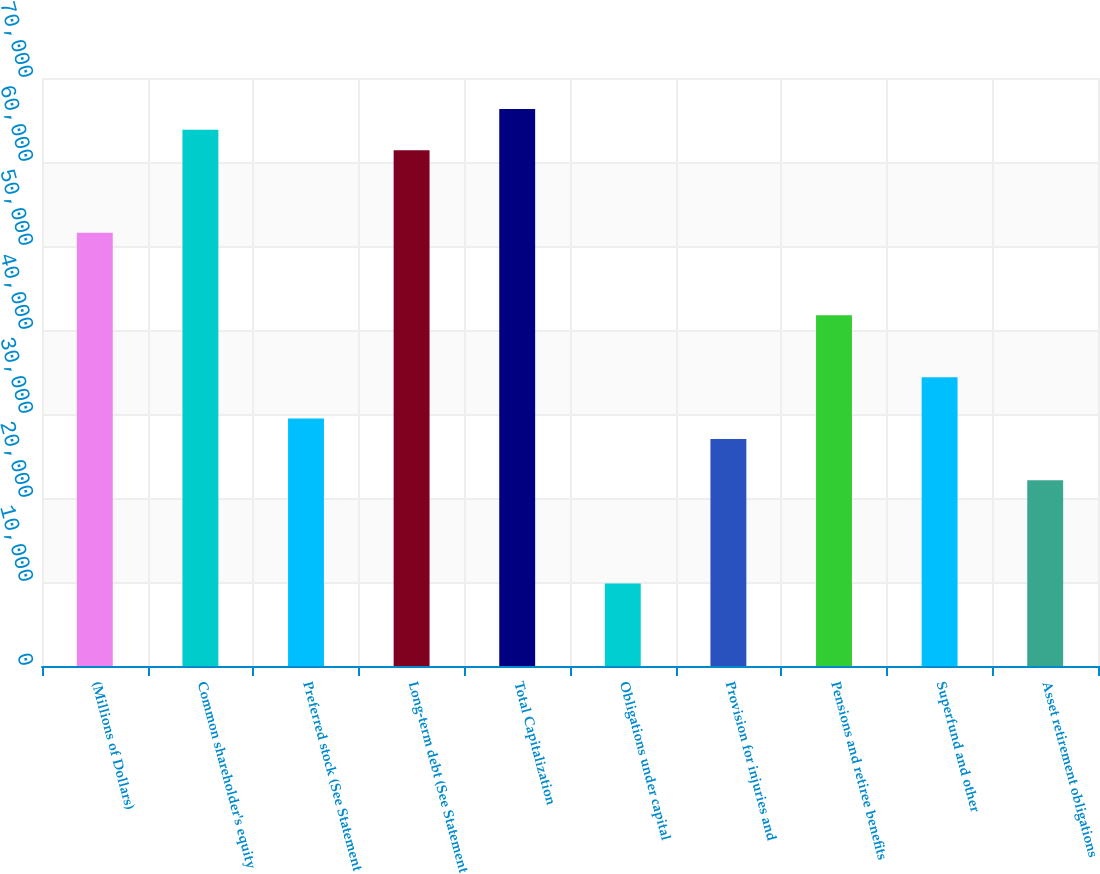Convert chart. <chart><loc_0><loc_0><loc_500><loc_500><bar_chart><fcel>(Millions of Dollars)<fcel>Common shareholder's equity<fcel>Preferred stock (See Statement<fcel>Long-term debt (See Statement<fcel>Total Capitalization<fcel>Obligations under capital<fcel>Provision for injuries and<fcel>Pensions and retiree benefits<fcel>Superfund and other<fcel>Asset retirement obligations<nl><fcel>51568.4<fcel>63845.4<fcel>29469.8<fcel>61390<fcel>66300.8<fcel>9826.6<fcel>27014.4<fcel>41746.8<fcel>34380.6<fcel>22103.6<nl></chart> 